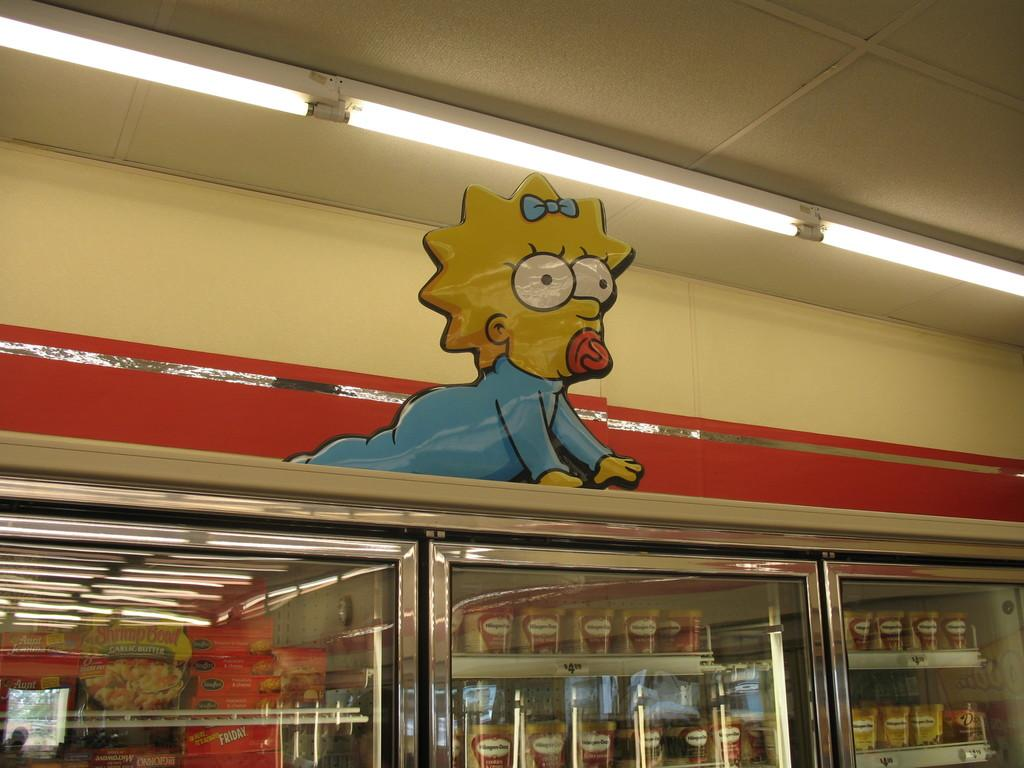What can be found inside the freezers in the image? There are food items in the freezers. What other object is visible in the image? There is a toy at the top of the freezers. Are there any lights in the image? Yes, there are lights above the toy. What type of stone is being used to power the engine in the image? There is no stone or engine present in the image. Can you describe the ray that is visible in the image? There is no ray visible in the image. 